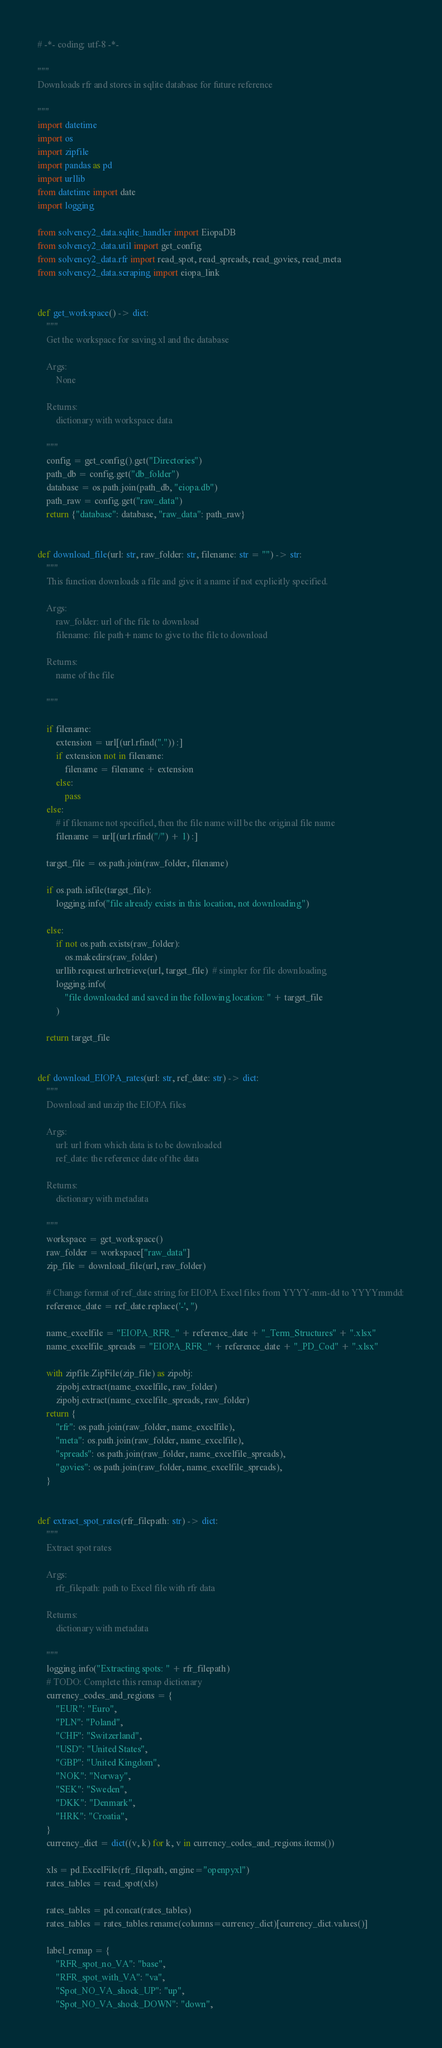Convert code to text. <code><loc_0><loc_0><loc_500><loc_500><_Python_># -*- coding: utf-8 -*-

"""
Downloads rfr and stores in sqlite database for future reference

"""
import datetime
import os
import zipfile
import pandas as pd
import urllib
from datetime import date
import logging

from solvency2_data.sqlite_handler import EiopaDB
from solvency2_data.util import get_config
from solvency2_data.rfr import read_spot, read_spreads, read_govies, read_meta
from solvency2_data.scraping import eiopa_link


def get_workspace() -> dict:
    """
    Get the workspace for saving xl and the database

    Args:
        None

    Returns:
        dictionary with workspace data

    """
    config = get_config().get("Directories")
    path_db = config.get("db_folder")
    database = os.path.join(path_db, "eiopa.db")
    path_raw = config.get("raw_data")
    return {"database": database, "raw_data": path_raw}


def download_file(url: str, raw_folder: str, filename: str = "") -> str:
    """
    This function downloads a file and give it a name if not explicitly specified.

    Args:
        raw_folder: url of the file to download
        filename: file path+name to give to the file to download

    Returns:
        name of the file

    """

    if filename:
        extension = url[(url.rfind(".")) :]
        if extension not in filename:
            filename = filename + extension
        else:
            pass
    else:
        # if filename not specified, then the file name will be the original file name
        filename = url[(url.rfind("/") + 1) :]

    target_file = os.path.join(raw_folder, filename)

    if os.path.isfile(target_file):
        logging.info("file already exists in this location, not downloading")

    else:
        if not os.path.exists(raw_folder):
            os.makedirs(raw_folder)
        urllib.request.urlretrieve(url, target_file)  # simpler for file downloading
        logging.info(
            "file downloaded and saved in the following location: " + target_file
        )

    return target_file


def download_EIOPA_rates(url: str, ref_date: str) -> dict:
    """
    Download and unzip the EIOPA files

    Args:
        url: url from which data is to be downloaded
        ref_date: the reference date of the data

    Returns:
        dictionary with metadata

    """
    workspace = get_workspace()
    raw_folder = workspace["raw_data"]
    zip_file = download_file(url, raw_folder)

    # Change format of ref_date string for EIOPA Excel files from YYYY-mm-dd to YYYYmmdd:
    reference_date = ref_date.replace('-', '')

    name_excelfile = "EIOPA_RFR_" + reference_date + "_Term_Structures" + ".xlsx"
    name_excelfile_spreads = "EIOPA_RFR_" + reference_date + "_PD_Cod" + ".xlsx"

    with zipfile.ZipFile(zip_file) as zipobj:
        zipobj.extract(name_excelfile, raw_folder)
        zipobj.extract(name_excelfile_spreads, raw_folder)
    return {
        "rfr": os.path.join(raw_folder, name_excelfile),
        "meta": os.path.join(raw_folder, name_excelfile),
        "spreads": os.path.join(raw_folder, name_excelfile_spreads),
        "govies": os.path.join(raw_folder, name_excelfile_spreads),
    }


def extract_spot_rates(rfr_filepath: str) -> dict:
    """
    Extract spot rates

    Args:
        rfr_filepath: path to Excel file with rfr data

    Returns:
        dictionary with metadata

    """
    logging.info("Extracting spots: " + rfr_filepath)
    # TODO: Complete this remap dictionary
    currency_codes_and_regions = {
        "EUR": "Euro",
        "PLN": "Poland",
        "CHF": "Switzerland",
        "USD": "United States",
        "GBP": "United Kingdom",
        "NOK": "Norway",
        "SEK": "Sweden",
        "DKK": "Denmark",
        "HRK": "Croatia",
    }
    currency_dict = dict((v, k) for k, v in currency_codes_and_regions.items())

    xls = pd.ExcelFile(rfr_filepath, engine="openpyxl")
    rates_tables = read_spot(xls)

    rates_tables = pd.concat(rates_tables)
    rates_tables = rates_tables.rename(columns=currency_dict)[currency_dict.values()]

    label_remap = {
        "RFR_spot_no_VA": "base",
        "RFR_spot_with_VA": "va",
        "Spot_NO_VA_shock_UP": "up",
        "Spot_NO_VA_shock_DOWN": "down",</code> 